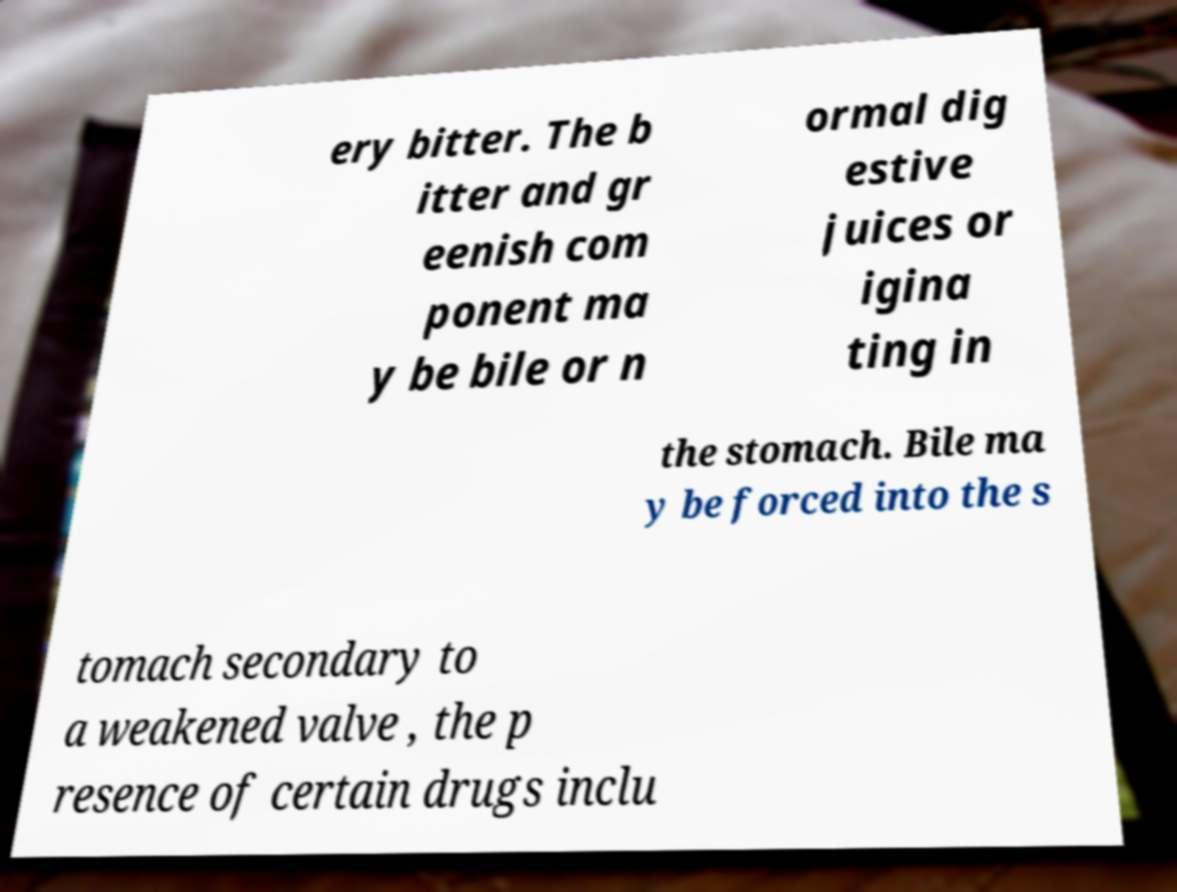There's text embedded in this image that I need extracted. Can you transcribe it verbatim? ery bitter. The b itter and gr eenish com ponent ma y be bile or n ormal dig estive juices or igina ting in the stomach. Bile ma y be forced into the s tomach secondary to a weakened valve , the p resence of certain drugs inclu 